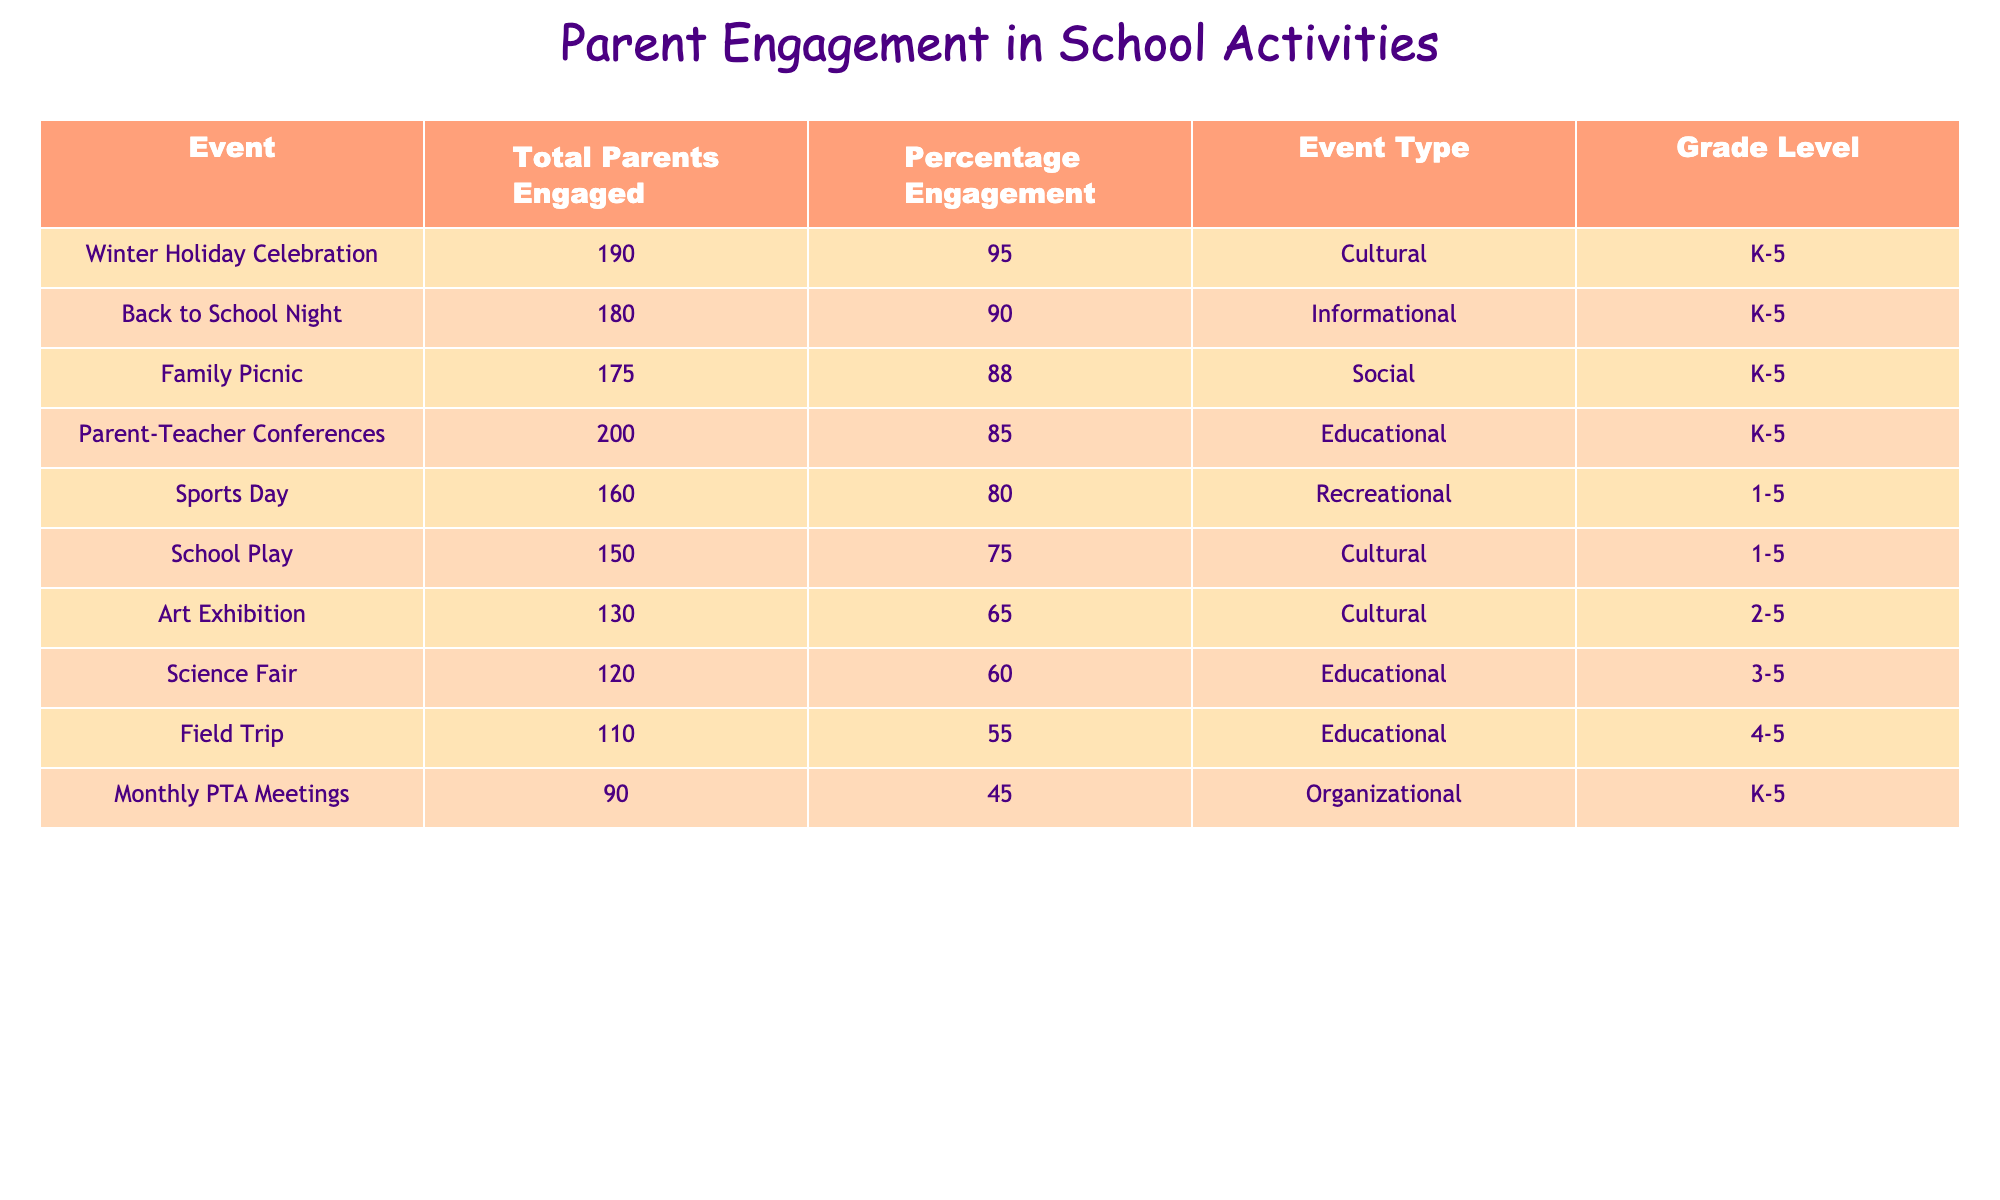What event had the highest percentage of parent engagement? Looking through the "Percentage Engagement" column, the Winter Holiday Celebration has the highest percentage at 95%.
Answer: 95% How many total parents engaged in the Back to School Night event? The "Total Parents Engaged" column shows that 180 parents engaged in the Back to School Night event.
Answer: 180 Is the engagement percentage for the Science Fair greater than 70%? The "Percentage Engagement" for the Science Fair is 60%, which is less than 70%. Therefore, it is not greater.
Answer: No What are the total engaged parents for all cultural events combined? The cultural events listed are the School Play, Art Exhibition, and Winter Holiday Celebration. Total engaged: 150 (School Play) + 130 (Art Exhibition) + 190 (Winter Holiday Celebration) = 470.
Answer: 470 Which event had the lowest total parent engagement? The "Total Parents Engaged" column indicates that the Monthly PTA Meetings had the lowest engagement at 90 parents.
Answer: 90 What is the average percentage engagement of all events listed? To calculate the average, sum the percentages (75 + 85 + 90 + 60 + 80 + 65 + 55 + 88 + 95 + 45) =  765. There are 10 events, so the average is 765/10 = 76.5%.
Answer: 76.5% Which grade level had the most events related to educational activities? The education-related events are Parent-Teacher Conferences, Science Fair, and Field Trip. These events are suitable for grade levels K-5 and 4-5. Since K-5 spans a wider range, it indicates a higher involvement of grade levels.
Answer: K-5 Were there any recreational events with engagement below 75%? Looking at the recreational events, Sports Day had 80%, which is above 75%. Hence, there were no recreational events below that engagement percentage.
Answer: No If we consider only the events with 80% engagement or higher, how many total parents engaged in these events? The events with 80% engagement or higher are Parent-Teacher Conferences (200), Back to School Night (180), Family Picnic (175), Winter Holiday Celebration (190), and Sports Day (160). Adding them gives 200 + 180 + 175 + 190 + 160 = 905.
Answer: 905 